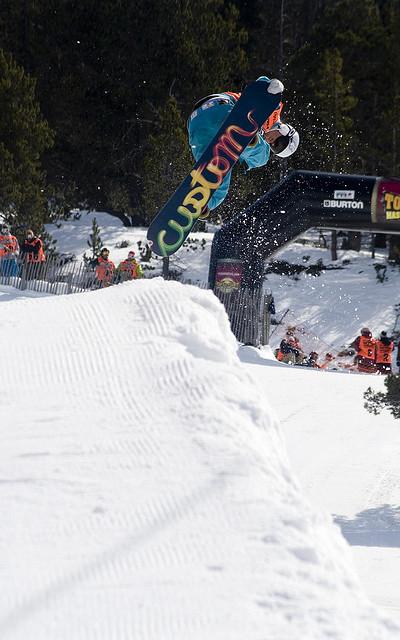Is it day or night?
Concise answer only. Day. Is this a dangerous stunt?
Keep it brief. Yes. Is it cold?
Keep it brief. Yes. What type of sport is this?
Keep it brief. Snowboarding. Is this person athletic?
Quick response, please. Yes. 